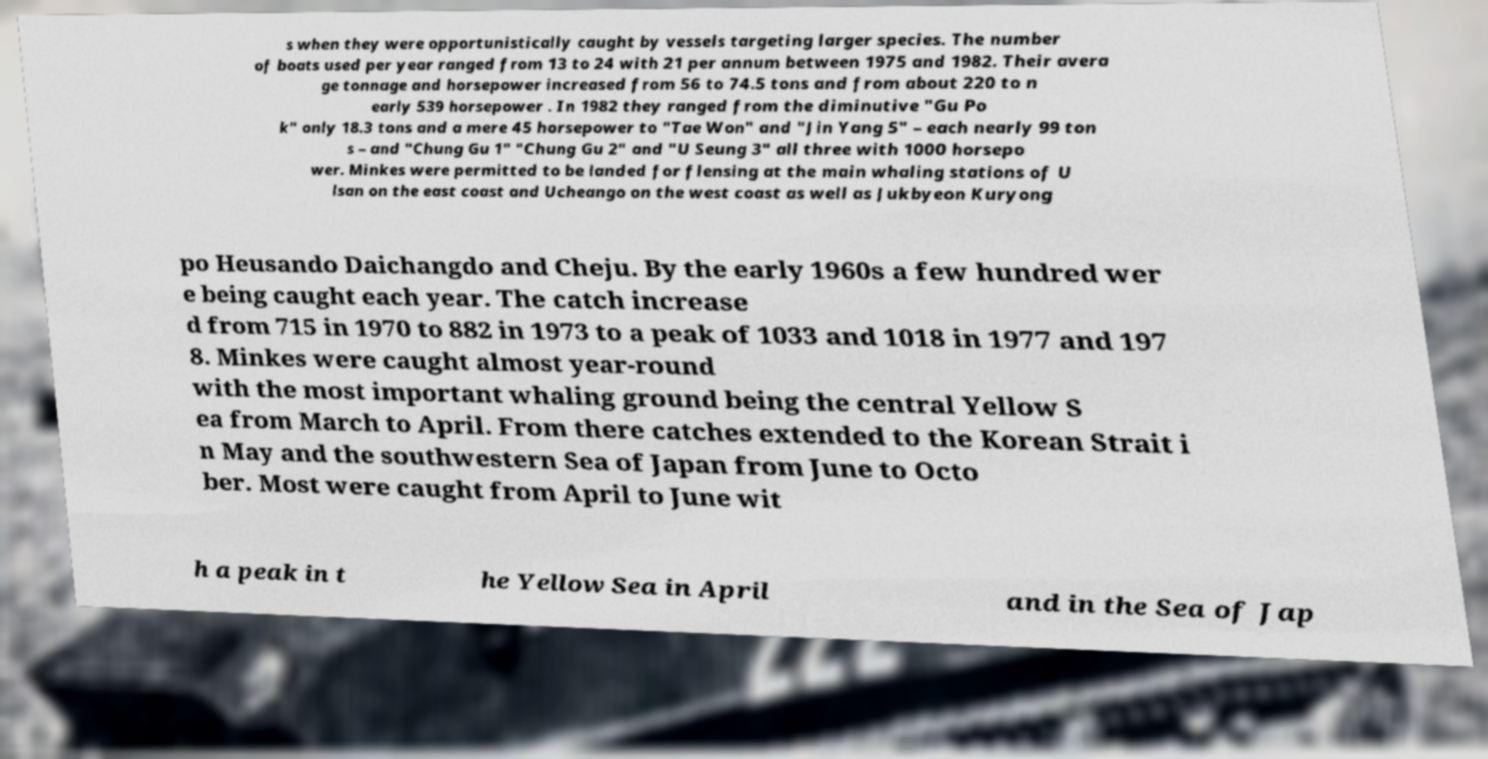Could you extract and type out the text from this image? s when they were opportunistically caught by vessels targeting larger species. The number of boats used per year ranged from 13 to 24 with 21 per annum between 1975 and 1982. Their avera ge tonnage and horsepower increased from 56 to 74.5 tons and from about 220 to n early 539 horsepower . In 1982 they ranged from the diminutive "Gu Po k" only 18.3 tons and a mere 45 horsepower to "Tae Won" and "Jin Yang 5" – each nearly 99 ton s – and "Chung Gu 1" "Chung Gu 2" and "U Seung 3" all three with 1000 horsepo wer. Minkes were permitted to be landed for flensing at the main whaling stations of U lsan on the east coast and Ucheango on the west coast as well as Jukbyeon Kuryong po Heusando Daichangdo and Cheju. By the early 1960s a few hundred wer e being caught each year. The catch increase d from 715 in 1970 to 882 in 1973 to a peak of 1033 and 1018 in 1977 and 197 8. Minkes were caught almost year-round with the most important whaling ground being the central Yellow S ea from March to April. From there catches extended to the Korean Strait i n May and the southwestern Sea of Japan from June to Octo ber. Most were caught from April to June wit h a peak in t he Yellow Sea in April and in the Sea of Jap 